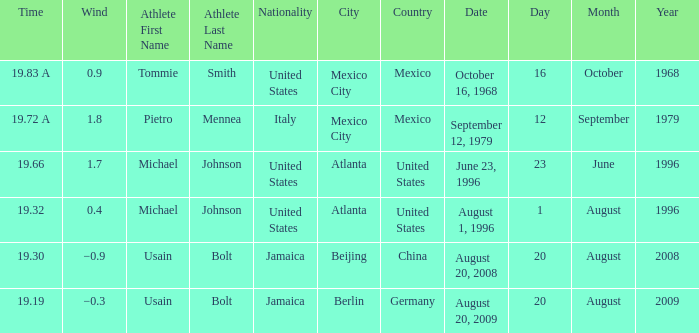Who's the athlete with a wind of 1.7 and from the United States? Michael Johnson. 